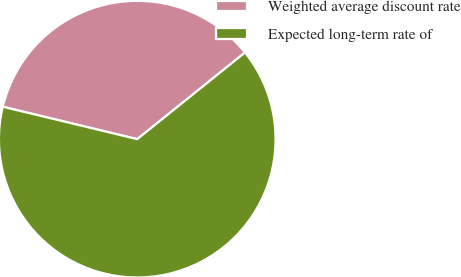<chart> <loc_0><loc_0><loc_500><loc_500><pie_chart><fcel>Weighted average discount rate<fcel>Expected long-term rate of<nl><fcel>35.46%<fcel>64.54%<nl></chart> 